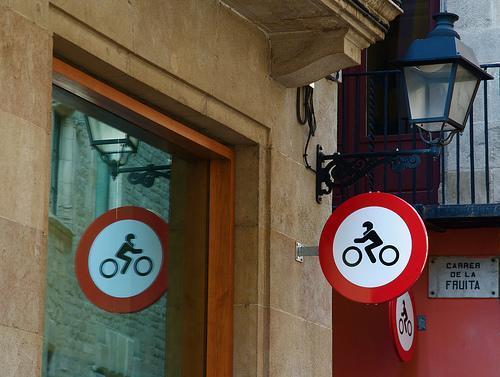How many lamps are there?
Give a very brief answer. 1. 